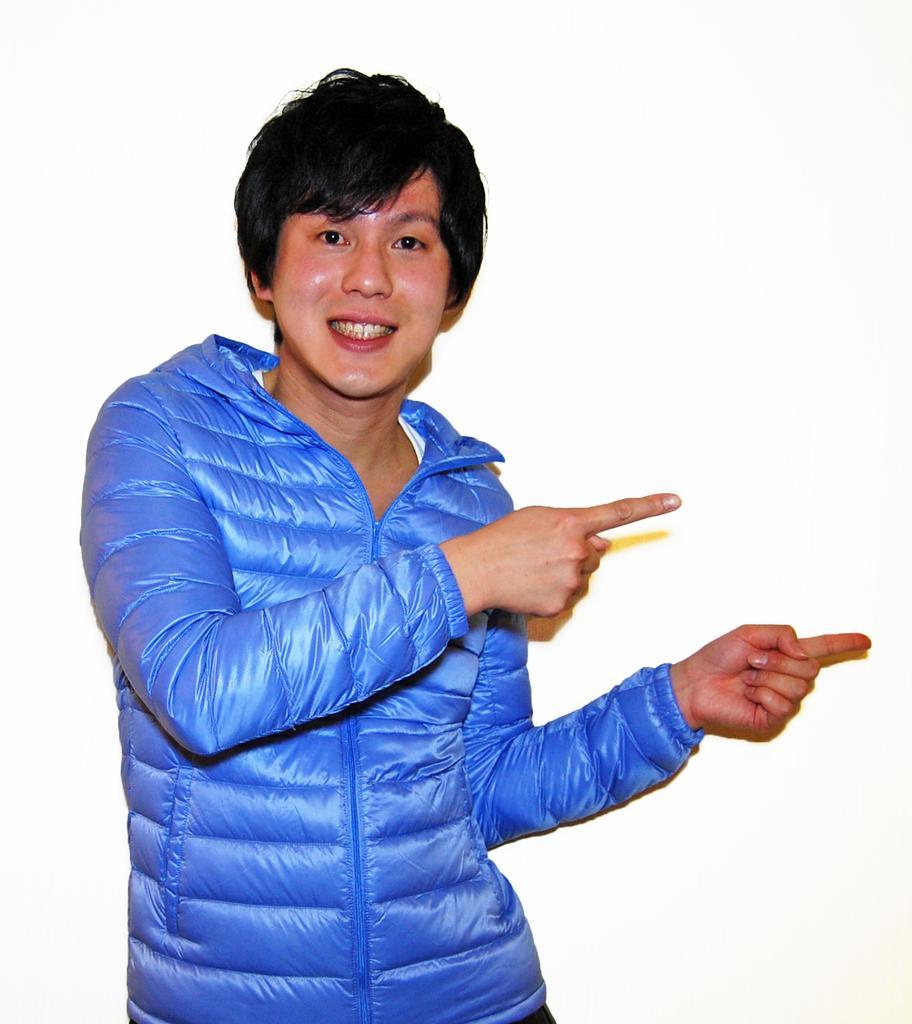How would you summarize this image in a sentence or two? In this image we can see a person. The background of the image is white. 